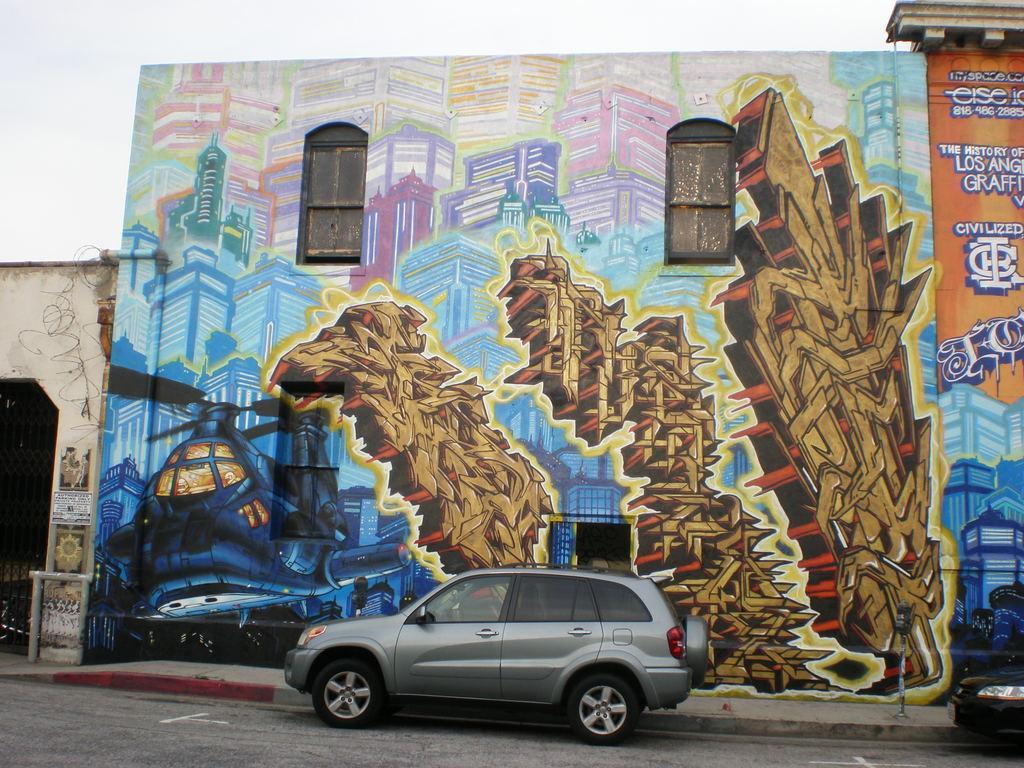Describe this image in one or two sentences. This picture shows buildings and we see painting on the wall and text on it and we see couple of cars and a cloudy sky. 